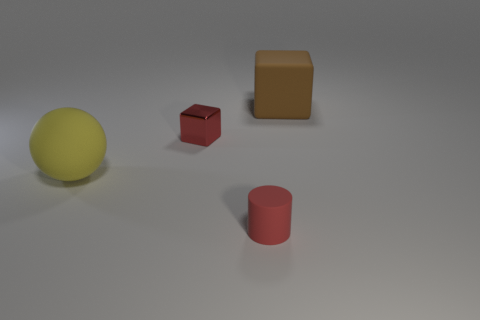Is there anything else that is made of the same material as the red cube?
Your answer should be compact. No. What is the material of the tiny object that is the same color as the cylinder?
Your response must be concise. Metal. What number of things are big matte objects or objects that are in front of the big brown rubber block?
Make the answer very short. 4. How many other things are the same size as the brown cube?
Offer a very short reply. 1. What material is the other small object that is the same shape as the brown thing?
Offer a terse response. Metal. Is the number of rubber objects that are left of the big brown object greater than the number of brown matte cubes?
Offer a terse response. Yes. Is there any other thing that is the same color as the matte block?
Your response must be concise. No. There is a large yellow thing that is the same material as the cylinder; what shape is it?
Your response must be concise. Sphere. Do the large object in front of the large brown matte object and the tiny cube have the same material?
Provide a succinct answer. No. The other object that is the same color as the shiny thing is what shape?
Your answer should be very brief. Cylinder. 